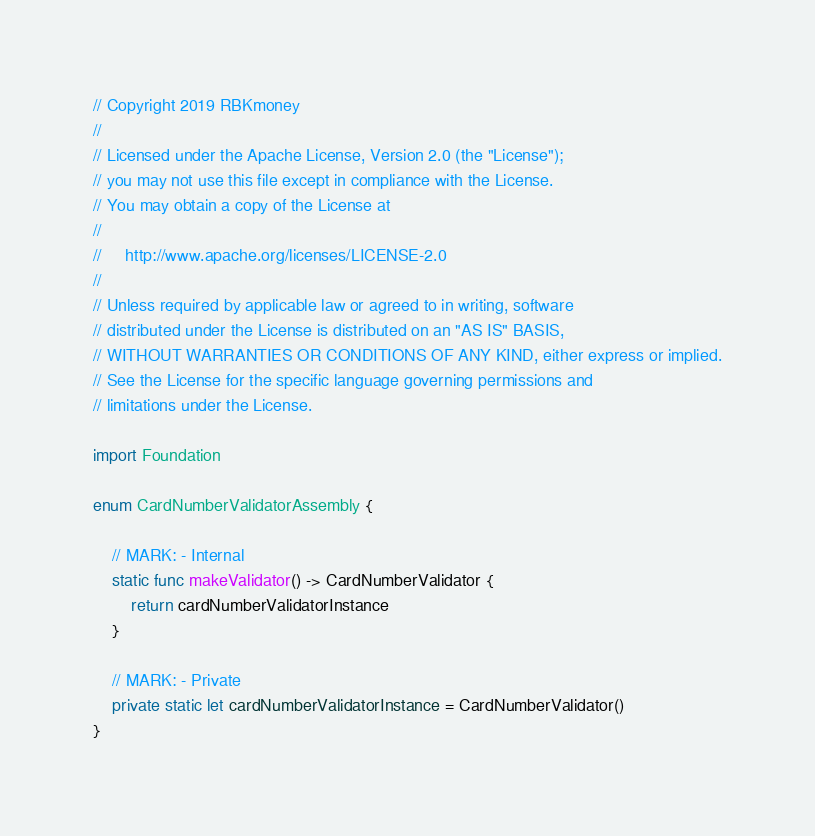Convert code to text. <code><loc_0><loc_0><loc_500><loc_500><_Swift_>// Copyright 2019 RBKmoney
//
// Licensed under the Apache License, Version 2.0 (the "License");
// you may not use this file except in compliance with the License.
// You may obtain a copy of the License at
//
//     http://www.apache.org/licenses/LICENSE-2.0
//
// Unless required by applicable law or agreed to in writing, software
// distributed under the License is distributed on an "AS IS" BASIS,
// WITHOUT WARRANTIES OR CONDITIONS OF ANY KIND, either express or implied.
// See the License for the specific language governing permissions and
// limitations under the License.

import Foundation

enum CardNumberValidatorAssembly {

    // MARK: - Internal
    static func makeValidator() -> CardNumberValidator {
        return cardNumberValidatorInstance
    }

    // MARK: - Private
    private static let cardNumberValidatorInstance = CardNumberValidator()
}
</code> 